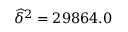<formula> <loc_0><loc_0><loc_500><loc_500>\widehat { \delta } ^ { 2 } = 2 9 8 6 4 . 0</formula> 